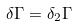<formula> <loc_0><loc_0><loc_500><loc_500>\delta \Gamma = \delta _ { 2 } \Gamma</formula> 